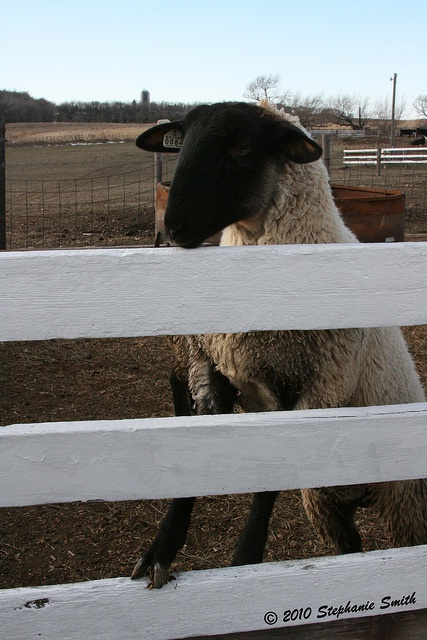Describe the objects in this image and their specific colors. I can see a sheep in lightblue, black, and gray tones in this image. 